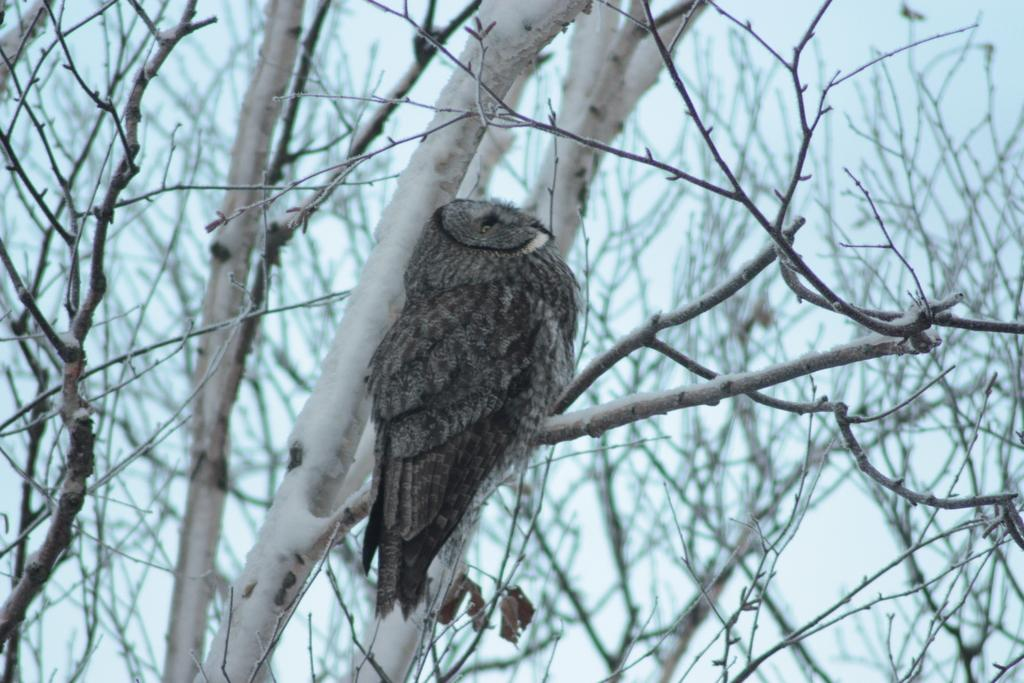What animal can be seen in the picture? There is an owl in the picture. Where is the owl located in the image? The owl is sitting on the branches of a tree. What is the ground condition in the background of the image? There is snow on the ground in the background of the image. What type of banana action can be seen in the image? There is no banana or any action involving a banana present in the image. 